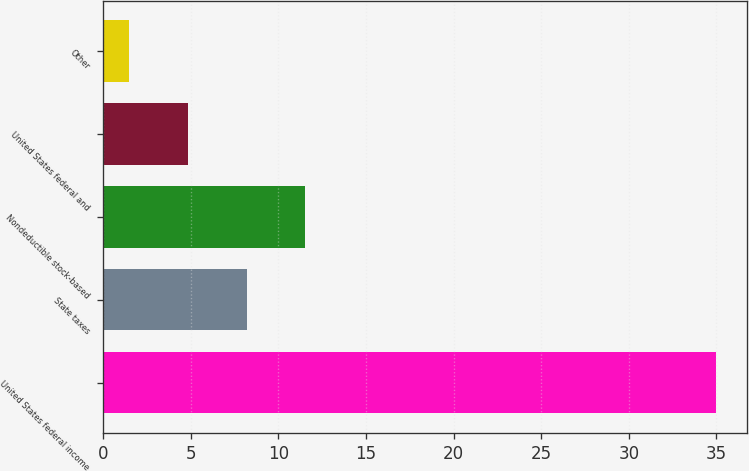Convert chart to OTSL. <chart><loc_0><loc_0><loc_500><loc_500><bar_chart><fcel>United States federal income<fcel>State taxes<fcel>Nondeductible stock-based<fcel>United States federal and<fcel>Other<nl><fcel>35<fcel>8.2<fcel>11.55<fcel>4.85<fcel>1.5<nl></chart> 